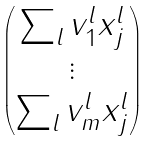Convert formula to latex. <formula><loc_0><loc_0><loc_500><loc_500>\begin{pmatrix} \sum _ { l } v _ { 1 } ^ { l } x _ { j } ^ { l } \\ \vdots \\ \sum _ { l } v _ { m } ^ { l } x _ { j } ^ { l } \\ \end{pmatrix}</formula> 